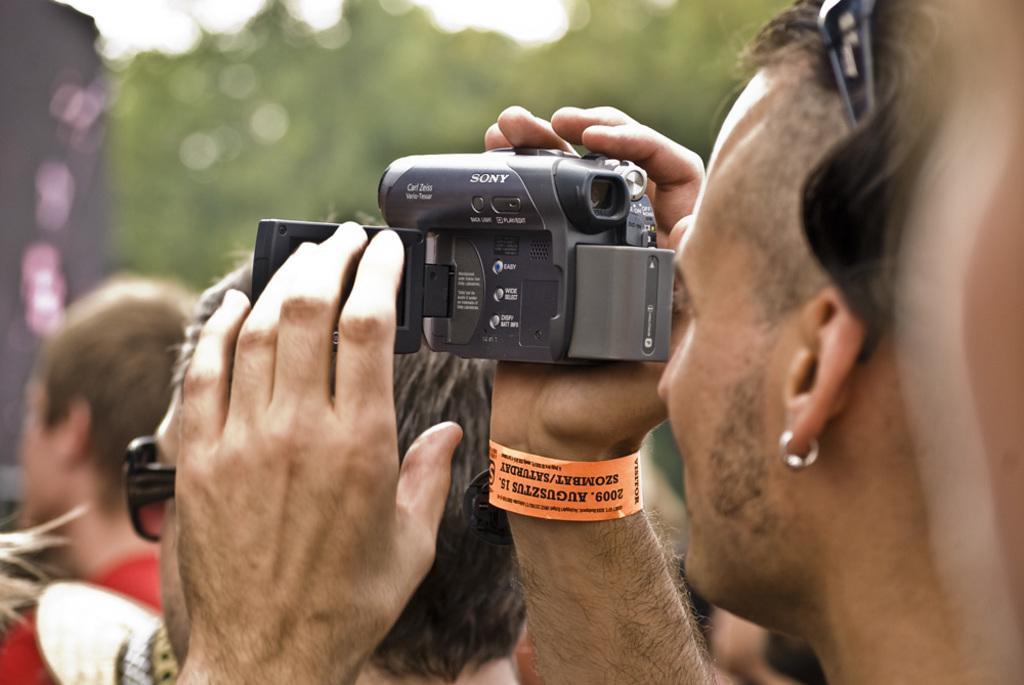In one or two sentences, can you explain what this image depicts? A person is recording video. Around him there are few people. 